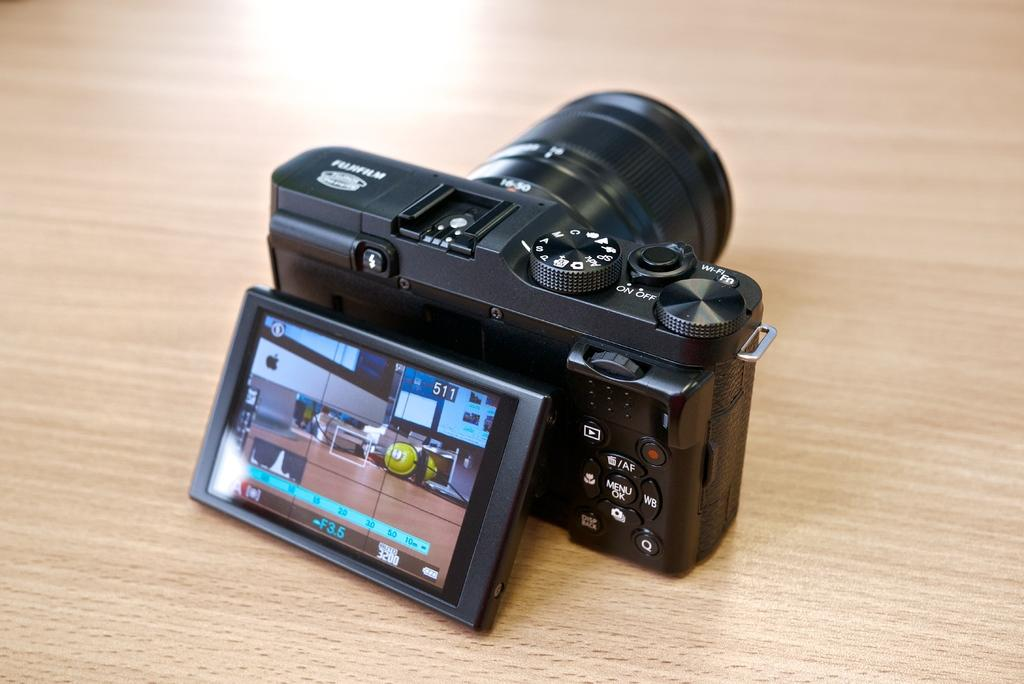What type of camera is visible in the image? There is a black color camera in the image. What can be seen on the camera? There is a screen in the image. Where is the writing located in the image? The writing is in multiple places in the image. How does the camera crush the coil in the image? There is no coil present in the image, and the camera does not have the ability to crush anything. 